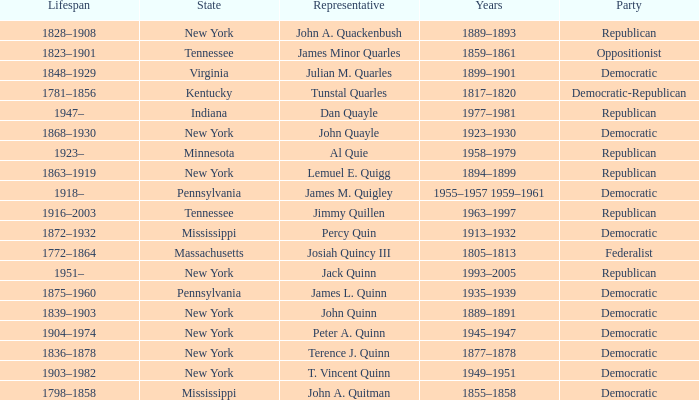Which state does Jimmy Quillen represent? Tennessee. 